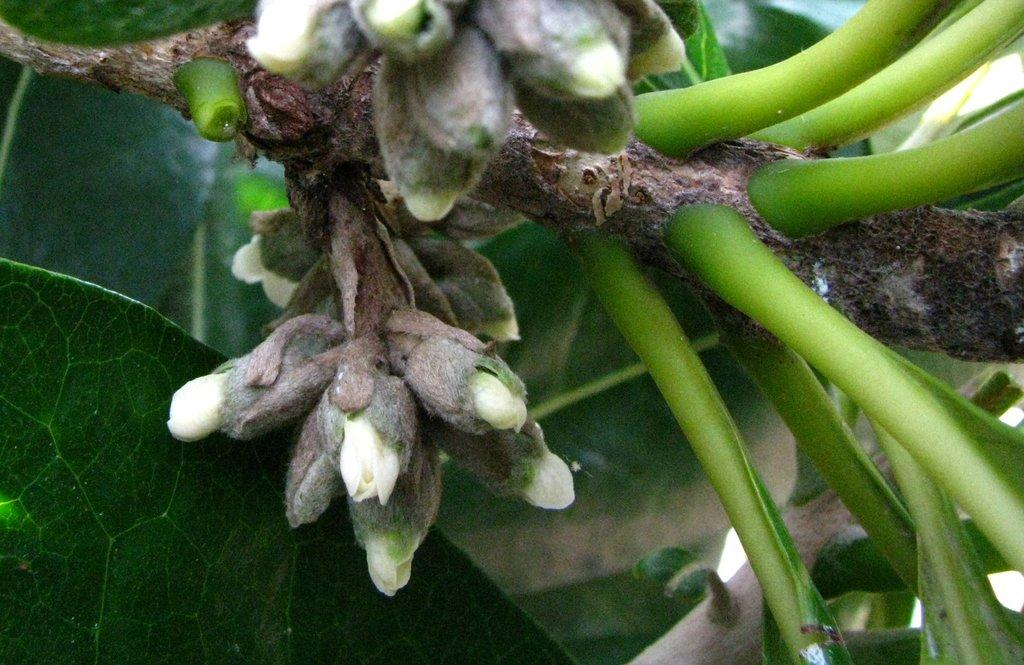What type of plants can be seen in the image? There are flowers in the image. What can be seen in the background of the image? There are leaves in the background of the image. How does the expert balance the mouth in the image? There is no expert, mouth, or balancing activity present in the image; it features flowers and leaves. 